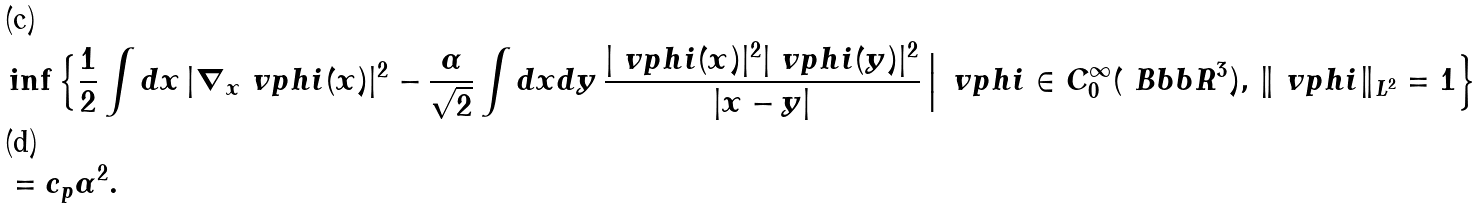<formula> <loc_0><loc_0><loc_500><loc_500>& \inf \Big \{ \frac { 1 } { 2 } \int d x \, | \nabla _ { x } \ v p h i ( x ) | ^ { 2 } - \frac { \alpha } { \sqrt { 2 } } \int d x d y \, \frac { | \ v p h i ( x ) | ^ { 2 } | \ v p h i ( y ) | ^ { 2 } } { | x - y | } \, \Big | \, \ v p h i \in C ^ { \infty } _ { 0 } ( \ B b b R ^ { 3 } ) , \, \| \ v p h i \| _ { L ^ { 2 } } = 1 \Big \} \\ & = c _ { p } \alpha ^ { 2 } .</formula> 